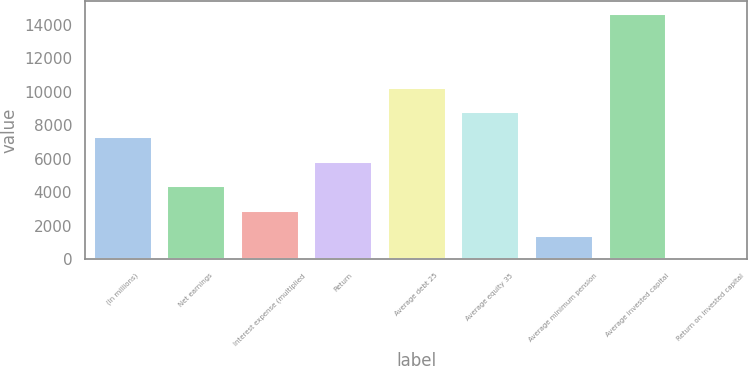Convert chart to OTSL. <chart><loc_0><loc_0><loc_500><loc_500><bar_chart><fcel>(In millions)<fcel>Net earnings<fcel>Interest expense (multiplied<fcel>Return<fcel>Average debt 25<fcel>Average equity 35<fcel>Average minimum pension<fcel>Average invested capital<fcel>Return on invested capital<nl><fcel>7345.5<fcel>4409.7<fcel>2941.8<fcel>5877.6<fcel>10281.3<fcel>8813.4<fcel>1473.9<fcel>14685<fcel>6<nl></chart> 